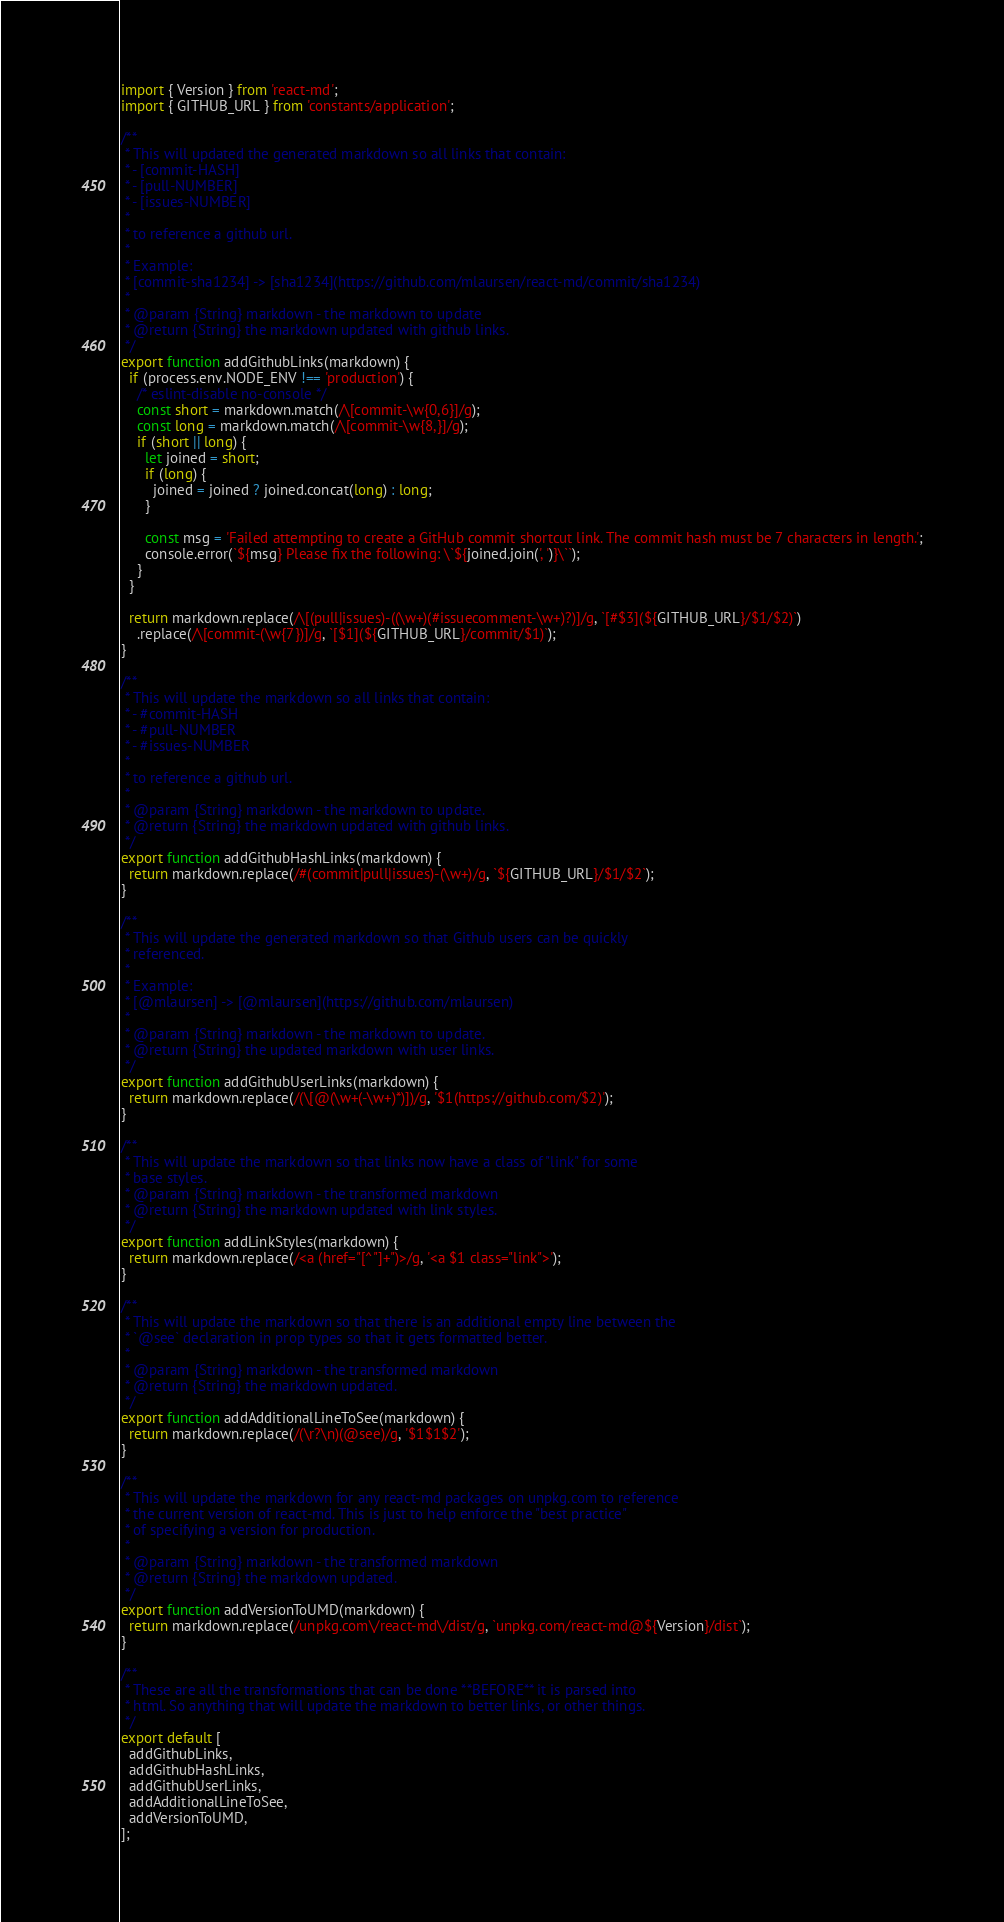Convert code to text. <code><loc_0><loc_0><loc_500><loc_500><_JavaScript_>import { Version } from 'react-md';
import { GITHUB_URL } from 'constants/application';

/**
 * This will updated the generated markdown so all links that contain:
 * - [commit-HASH]
 * - [pull-NUMBER]
 * - [issues-NUMBER]
 *
 * to reference a github url.
 *
 * Example:
 * [commit-sha1234] -> [sha1234](https://github.com/mlaursen/react-md/commit/sha1234)
 *
 * @param {String} markdown - the markdown to update
 * @return {String} the markdown updated with github links.
 */
export function addGithubLinks(markdown) {
  if (process.env.NODE_ENV !== 'production') {
    /* eslint-disable no-console */
    const short = markdown.match(/\[commit-\w{0,6}]/g);
    const long = markdown.match(/\[commit-\w{8,}]/g);
    if (short || long) {
      let joined = short;
      if (long) {
        joined = joined ? joined.concat(long) : long;
      }

      const msg = 'Failed attempting to create a GitHub commit shortcut link. The commit hash must be 7 characters in length.';
      console.error(`${msg} Please fix the following: \`${joined.join(', ')}\``);
    }
  }

  return markdown.replace(/\[(pull|issues)-((\w+)(#issuecomment-\w+)?)]/g, `[#$3](${GITHUB_URL}/$1/$2)`)
    .replace(/\[commit-(\w{7})]/g, `[$1](${GITHUB_URL}/commit/$1)`);
}

/**
 * This will update the markdown so all links that contain:
 * - #commit-HASH
 * - #pull-NUMBER
 * - #issues-NUMBER
 *
 * to reference a github url.
 *
 * @param {String} markdown - the markdown to update.
 * @return {String} the markdown updated with github links.
 */
export function addGithubHashLinks(markdown) {
  return markdown.replace(/#(commit|pull|issues)-(\w+)/g, `${GITHUB_URL}/$1/$2`);
}

/**
 * This will update the generated markdown so that Github users can be quickly
 * referenced.
 *
 * Example:
 * [@mlaursen] -> [@mlaursen](https://github.com/mlaursen)
 *
 * @param {String} markdown - the markdown to update.
 * @return {String} the updated markdown with user links.
 */
export function addGithubUserLinks(markdown) {
  return markdown.replace(/(\[@(\w+(-\w+)*)])/g, '$1(https://github.com/$2)');
}

/**
 * This will update the markdown so that links now have a class of "link" for some
 * base styles.
 * @param {String} markdown - the transformed markdown
 * @return {String} the markdown updated with link styles.
 */
export function addLinkStyles(markdown) {
  return markdown.replace(/<a (href="[^"]+")>/g, '<a $1 class="link">');
}

/**
 * This will update the markdown so that there is an additional empty line between the
 * `@see` declaration in prop types so that it gets formatted better.
 *
 * @param {String} markdown - the transformed markdown
 * @return {String} the markdown updated.
 */
export function addAdditionalLineToSee(markdown) {
  return markdown.replace(/(\r?\n)(@see)/g, '$1$1$2');
}

/**
 * This will update the markdown for any react-md packages on unpkg.com to reference
 * the current version of react-md. This is just to help enforce the "best practice"
 * of specifying a version for production.
 *
 * @param {String} markdown - the transformed markdown
 * @return {String} the markdown updated.
 */
export function addVersionToUMD(markdown) {
  return markdown.replace(/unpkg.com\/react-md\/dist/g, `unpkg.com/react-md@${Version}/dist`);
}

/**
 * These are all the transformations that can be done **BEFORE** it is parsed into
 * html. So anything that will update the markdown to better links, or other things.
 */
export default [
  addGithubLinks,
  addGithubHashLinks,
  addGithubUserLinks,
  addAdditionalLineToSee,
  addVersionToUMD,
];
</code> 